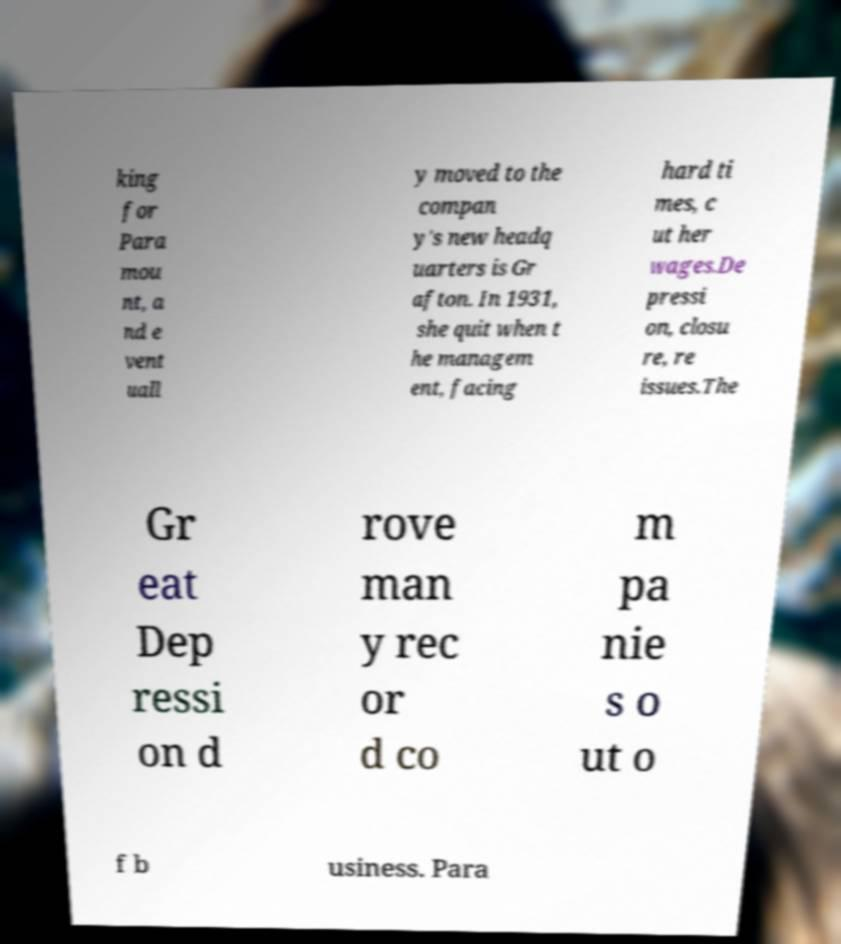Please identify and transcribe the text found in this image. king for Para mou nt, a nd e vent uall y moved to the compan y's new headq uarters is Gr afton. In 1931, she quit when t he managem ent, facing hard ti mes, c ut her wages.De pressi on, closu re, re issues.The Gr eat Dep ressi on d rove man y rec or d co m pa nie s o ut o f b usiness. Para 